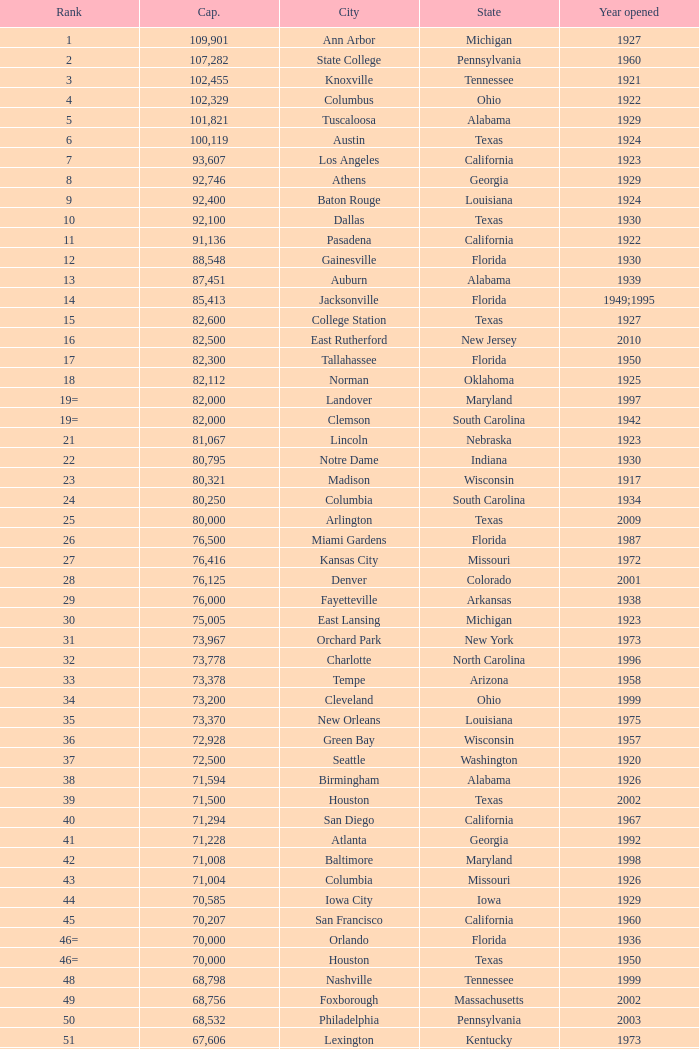What is the lowest capacity for 1903? 30323.0. 